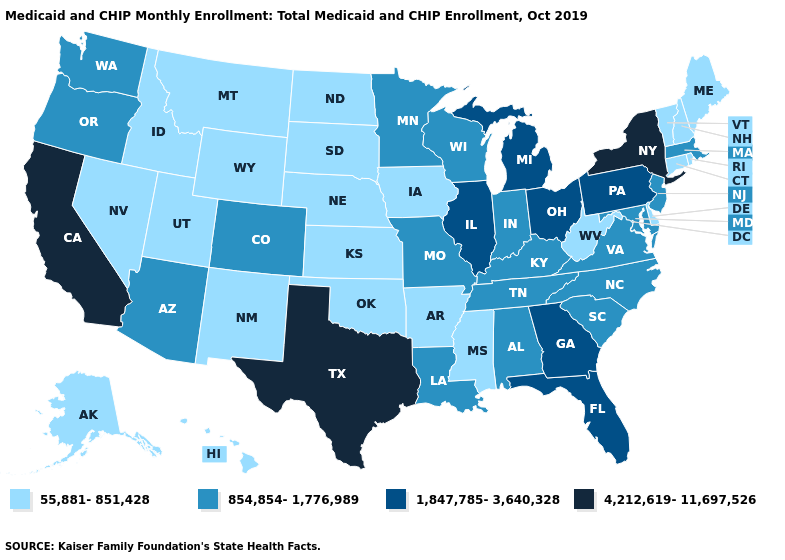What is the value of Alabama?
Give a very brief answer. 854,854-1,776,989. Name the states that have a value in the range 1,847,785-3,640,328?
Concise answer only. Florida, Georgia, Illinois, Michigan, Ohio, Pennsylvania. Does Michigan have the highest value in the MidWest?
Short answer required. Yes. Among the states that border Oregon , does Nevada have the lowest value?
Short answer required. Yes. What is the value of Michigan?
Keep it brief. 1,847,785-3,640,328. What is the value of Nevada?
Short answer required. 55,881-851,428. Does the map have missing data?
Write a very short answer. No. What is the lowest value in the USA?
Give a very brief answer. 55,881-851,428. Does New York have the highest value in the USA?
Be succinct. Yes. Name the states that have a value in the range 4,212,619-11,697,526?
Give a very brief answer. California, New York, Texas. Among the states that border New Hampshire , which have the lowest value?
Give a very brief answer. Maine, Vermont. What is the lowest value in the USA?
Short answer required. 55,881-851,428. What is the value of Rhode Island?
Answer briefly. 55,881-851,428. Name the states that have a value in the range 4,212,619-11,697,526?
Quick response, please. California, New York, Texas. How many symbols are there in the legend?
Write a very short answer. 4. 